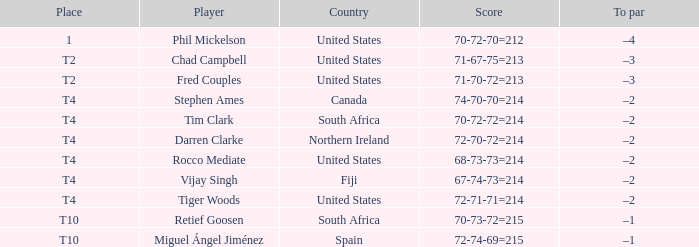What country does Rocco Mediate play for? United States. 